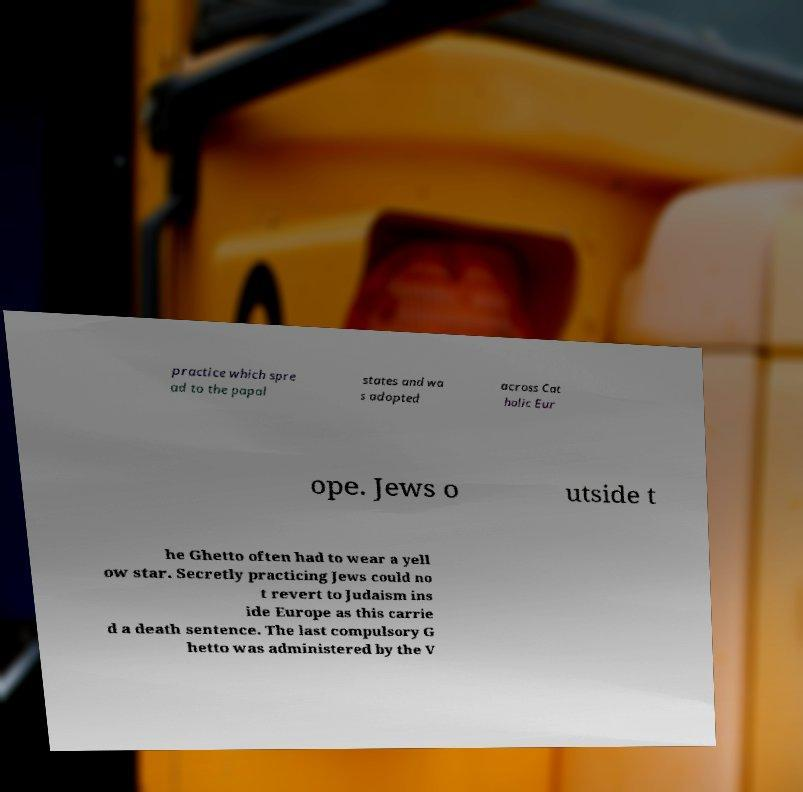Can you read and provide the text displayed in the image?This photo seems to have some interesting text. Can you extract and type it out for me? practice which spre ad to the papal states and wa s adopted across Cat holic Eur ope. Jews o utside t he Ghetto often had to wear a yell ow star. Secretly practicing Jews could no t revert to Judaism ins ide Europe as this carrie d a death sentence. The last compulsory G hetto was administered by the V 